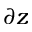Convert formula to latex. <formula><loc_0><loc_0><loc_500><loc_500>\partial z</formula> 